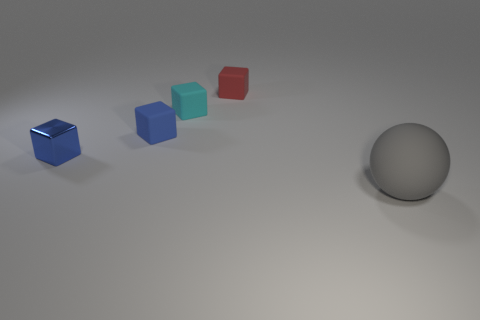Are there any other rubber things that have the same size as the red thing?
Keep it short and to the point. Yes. What is the size of the matte thing right of the matte block to the right of the cyan matte thing?
Keep it short and to the point. Large. Are there fewer gray objects that are behind the tiny cyan thing than large purple metallic cylinders?
Your response must be concise. No. How big is the matte sphere?
Make the answer very short. Large. What number of big matte balls have the same color as the metallic block?
Your response must be concise. 0. Are there any gray rubber things that are to the right of the tiny blue cube that is in front of the blue thing that is behind the tiny blue shiny block?
Offer a terse response. Yes. What is the shape of the blue rubber object that is the same size as the red rubber thing?
Ensure brevity in your answer.  Cube. How many tiny things are brown rubber objects or matte things?
Give a very brief answer. 3. What is the color of the big ball that is made of the same material as the small red thing?
Ensure brevity in your answer.  Gray. Is the shape of the small red thing that is behind the tiny cyan rubber cube the same as the blue object that is in front of the tiny blue rubber cube?
Give a very brief answer. Yes. 